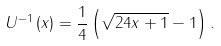<formula> <loc_0><loc_0><loc_500><loc_500>U ^ { - 1 } \left ( x \right ) = \frac { 1 } { 4 } \left ( \sqrt { 2 4 x + 1 } - 1 \right ) .</formula> 